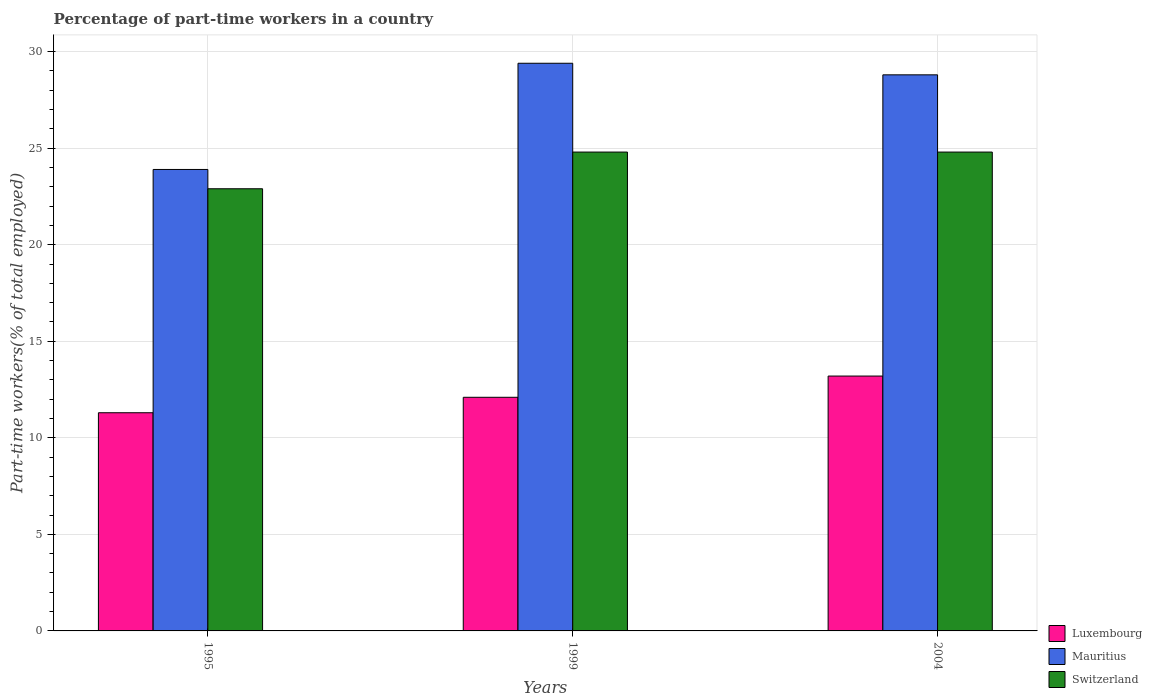How many different coloured bars are there?
Offer a very short reply. 3. Are the number of bars on each tick of the X-axis equal?
Offer a very short reply. Yes. What is the label of the 2nd group of bars from the left?
Your answer should be compact. 1999. What is the percentage of part-time workers in Switzerland in 1995?
Keep it short and to the point. 22.9. Across all years, what is the maximum percentage of part-time workers in Luxembourg?
Give a very brief answer. 13.2. Across all years, what is the minimum percentage of part-time workers in Luxembourg?
Give a very brief answer. 11.3. What is the total percentage of part-time workers in Switzerland in the graph?
Your response must be concise. 72.5. What is the difference between the percentage of part-time workers in Luxembourg in 1995 and that in 1999?
Provide a succinct answer. -0.8. What is the difference between the percentage of part-time workers in Luxembourg in 1999 and the percentage of part-time workers in Mauritius in 1995?
Give a very brief answer. -11.8. What is the average percentage of part-time workers in Mauritius per year?
Your response must be concise. 27.37. In the year 1995, what is the difference between the percentage of part-time workers in Switzerland and percentage of part-time workers in Luxembourg?
Provide a short and direct response. 11.6. In how many years, is the percentage of part-time workers in Luxembourg greater than 7 %?
Keep it short and to the point. 3. What is the ratio of the percentage of part-time workers in Luxembourg in 1999 to that in 2004?
Your response must be concise. 0.92. Is the percentage of part-time workers in Switzerland in 1995 less than that in 2004?
Ensure brevity in your answer.  Yes. Is the difference between the percentage of part-time workers in Switzerland in 1995 and 1999 greater than the difference between the percentage of part-time workers in Luxembourg in 1995 and 1999?
Your answer should be compact. No. What is the difference between the highest and the second highest percentage of part-time workers in Switzerland?
Your answer should be compact. 0. What is the difference between the highest and the lowest percentage of part-time workers in Switzerland?
Provide a short and direct response. 1.9. In how many years, is the percentage of part-time workers in Mauritius greater than the average percentage of part-time workers in Mauritius taken over all years?
Ensure brevity in your answer.  2. What does the 1st bar from the left in 1995 represents?
Your response must be concise. Luxembourg. What does the 3rd bar from the right in 2004 represents?
Ensure brevity in your answer.  Luxembourg. Are all the bars in the graph horizontal?
Offer a very short reply. No. What is the difference between two consecutive major ticks on the Y-axis?
Give a very brief answer. 5. Are the values on the major ticks of Y-axis written in scientific E-notation?
Your response must be concise. No. Does the graph contain any zero values?
Your answer should be compact. No. How are the legend labels stacked?
Offer a terse response. Vertical. What is the title of the graph?
Offer a very short reply. Percentage of part-time workers in a country. Does "Slovenia" appear as one of the legend labels in the graph?
Your answer should be compact. No. What is the label or title of the Y-axis?
Your answer should be very brief. Part-time workers(% of total employed). What is the Part-time workers(% of total employed) in Luxembourg in 1995?
Provide a short and direct response. 11.3. What is the Part-time workers(% of total employed) of Mauritius in 1995?
Give a very brief answer. 23.9. What is the Part-time workers(% of total employed) in Switzerland in 1995?
Keep it short and to the point. 22.9. What is the Part-time workers(% of total employed) of Luxembourg in 1999?
Offer a very short reply. 12.1. What is the Part-time workers(% of total employed) in Mauritius in 1999?
Make the answer very short. 29.4. What is the Part-time workers(% of total employed) in Switzerland in 1999?
Offer a terse response. 24.8. What is the Part-time workers(% of total employed) in Luxembourg in 2004?
Your response must be concise. 13.2. What is the Part-time workers(% of total employed) of Mauritius in 2004?
Keep it short and to the point. 28.8. What is the Part-time workers(% of total employed) in Switzerland in 2004?
Your answer should be very brief. 24.8. Across all years, what is the maximum Part-time workers(% of total employed) of Luxembourg?
Offer a terse response. 13.2. Across all years, what is the maximum Part-time workers(% of total employed) in Mauritius?
Ensure brevity in your answer.  29.4. Across all years, what is the maximum Part-time workers(% of total employed) in Switzerland?
Make the answer very short. 24.8. Across all years, what is the minimum Part-time workers(% of total employed) of Luxembourg?
Ensure brevity in your answer.  11.3. Across all years, what is the minimum Part-time workers(% of total employed) in Mauritius?
Give a very brief answer. 23.9. Across all years, what is the minimum Part-time workers(% of total employed) of Switzerland?
Offer a very short reply. 22.9. What is the total Part-time workers(% of total employed) in Luxembourg in the graph?
Offer a very short reply. 36.6. What is the total Part-time workers(% of total employed) in Mauritius in the graph?
Your answer should be compact. 82.1. What is the total Part-time workers(% of total employed) in Switzerland in the graph?
Keep it short and to the point. 72.5. What is the difference between the Part-time workers(% of total employed) in Mauritius in 1995 and that in 1999?
Your response must be concise. -5.5. What is the difference between the Part-time workers(% of total employed) of Switzerland in 1995 and that in 1999?
Your answer should be compact. -1.9. What is the difference between the Part-time workers(% of total employed) of Switzerland in 1995 and that in 2004?
Ensure brevity in your answer.  -1.9. What is the difference between the Part-time workers(% of total employed) in Mauritius in 1999 and that in 2004?
Make the answer very short. 0.6. What is the difference between the Part-time workers(% of total employed) in Luxembourg in 1995 and the Part-time workers(% of total employed) in Mauritius in 1999?
Your answer should be very brief. -18.1. What is the difference between the Part-time workers(% of total employed) in Luxembourg in 1995 and the Part-time workers(% of total employed) in Mauritius in 2004?
Offer a terse response. -17.5. What is the difference between the Part-time workers(% of total employed) of Luxembourg in 1995 and the Part-time workers(% of total employed) of Switzerland in 2004?
Your answer should be compact. -13.5. What is the difference between the Part-time workers(% of total employed) in Mauritius in 1995 and the Part-time workers(% of total employed) in Switzerland in 2004?
Offer a terse response. -0.9. What is the difference between the Part-time workers(% of total employed) of Luxembourg in 1999 and the Part-time workers(% of total employed) of Mauritius in 2004?
Your response must be concise. -16.7. What is the difference between the Part-time workers(% of total employed) of Luxembourg in 1999 and the Part-time workers(% of total employed) of Switzerland in 2004?
Provide a succinct answer. -12.7. What is the average Part-time workers(% of total employed) in Luxembourg per year?
Offer a terse response. 12.2. What is the average Part-time workers(% of total employed) in Mauritius per year?
Provide a succinct answer. 27.37. What is the average Part-time workers(% of total employed) in Switzerland per year?
Ensure brevity in your answer.  24.17. In the year 1995, what is the difference between the Part-time workers(% of total employed) of Mauritius and Part-time workers(% of total employed) of Switzerland?
Make the answer very short. 1. In the year 1999, what is the difference between the Part-time workers(% of total employed) in Luxembourg and Part-time workers(% of total employed) in Mauritius?
Keep it short and to the point. -17.3. In the year 1999, what is the difference between the Part-time workers(% of total employed) of Luxembourg and Part-time workers(% of total employed) of Switzerland?
Keep it short and to the point. -12.7. In the year 2004, what is the difference between the Part-time workers(% of total employed) in Luxembourg and Part-time workers(% of total employed) in Mauritius?
Provide a succinct answer. -15.6. In the year 2004, what is the difference between the Part-time workers(% of total employed) in Luxembourg and Part-time workers(% of total employed) in Switzerland?
Your answer should be very brief. -11.6. What is the ratio of the Part-time workers(% of total employed) in Luxembourg in 1995 to that in 1999?
Your response must be concise. 0.93. What is the ratio of the Part-time workers(% of total employed) in Mauritius in 1995 to that in 1999?
Offer a very short reply. 0.81. What is the ratio of the Part-time workers(% of total employed) of Switzerland in 1995 to that in 1999?
Ensure brevity in your answer.  0.92. What is the ratio of the Part-time workers(% of total employed) in Luxembourg in 1995 to that in 2004?
Your answer should be compact. 0.86. What is the ratio of the Part-time workers(% of total employed) in Mauritius in 1995 to that in 2004?
Your response must be concise. 0.83. What is the ratio of the Part-time workers(% of total employed) in Switzerland in 1995 to that in 2004?
Make the answer very short. 0.92. What is the ratio of the Part-time workers(% of total employed) in Luxembourg in 1999 to that in 2004?
Provide a succinct answer. 0.92. What is the ratio of the Part-time workers(% of total employed) in Mauritius in 1999 to that in 2004?
Your answer should be very brief. 1.02. What is the ratio of the Part-time workers(% of total employed) in Switzerland in 1999 to that in 2004?
Keep it short and to the point. 1. What is the difference between the highest and the second highest Part-time workers(% of total employed) in Luxembourg?
Offer a very short reply. 1.1. What is the difference between the highest and the second highest Part-time workers(% of total employed) in Mauritius?
Provide a short and direct response. 0.6. What is the difference between the highest and the second highest Part-time workers(% of total employed) in Switzerland?
Your answer should be compact. 0. What is the difference between the highest and the lowest Part-time workers(% of total employed) in Luxembourg?
Offer a terse response. 1.9. What is the difference between the highest and the lowest Part-time workers(% of total employed) in Mauritius?
Keep it short and to the point. 5.5. What is the difference between the highest and the lowest Part-time workers(% of total employed) in Switzerland?
Offer a terse response. 1.9. 